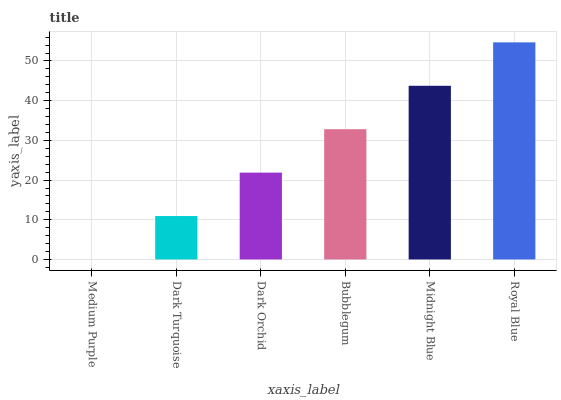Is Medium Purple the minimum?
Answer yes or no. Yes. Is Royal Blue the maximum?
Answer yes or no. Yes. Is Dark Turquoise the minimum?
Answer yes or no. No. Is Dark Turquoise the maximum?
Answer yes or no. No. Is Dark Turquoise greater than Medium Purple?
Answer yes or no. Yes. Is Medium Purple less than Dark Turquoise?
Answer yes or no. Yes. Is Medium Purple greater than Dark Turquoise?
Answer yes or no. No. Is Dark Turquoise less than Medium Purple?
Answer yes or no. No. Is Bubblegum the high median?
Answer yes or no. Yes. Is Dark Orchid the low median?
Answer yes or no. Yes. Is Dark Turquoise the high median?
Answer yes or no. No. Is Bubblegum the low median?
Answer yes or no. No. 